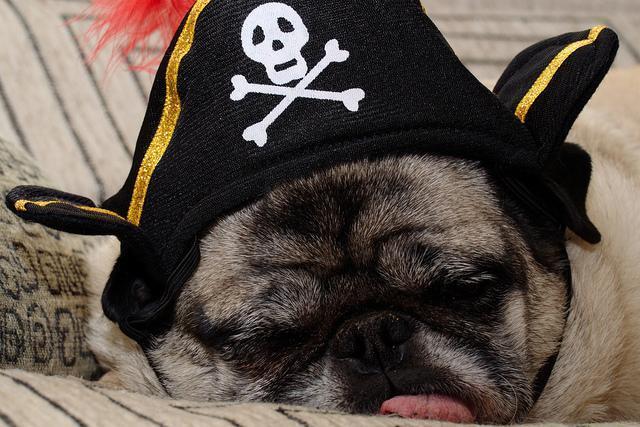How many black cars are under a cat?
Give a very brief answer. 0. 